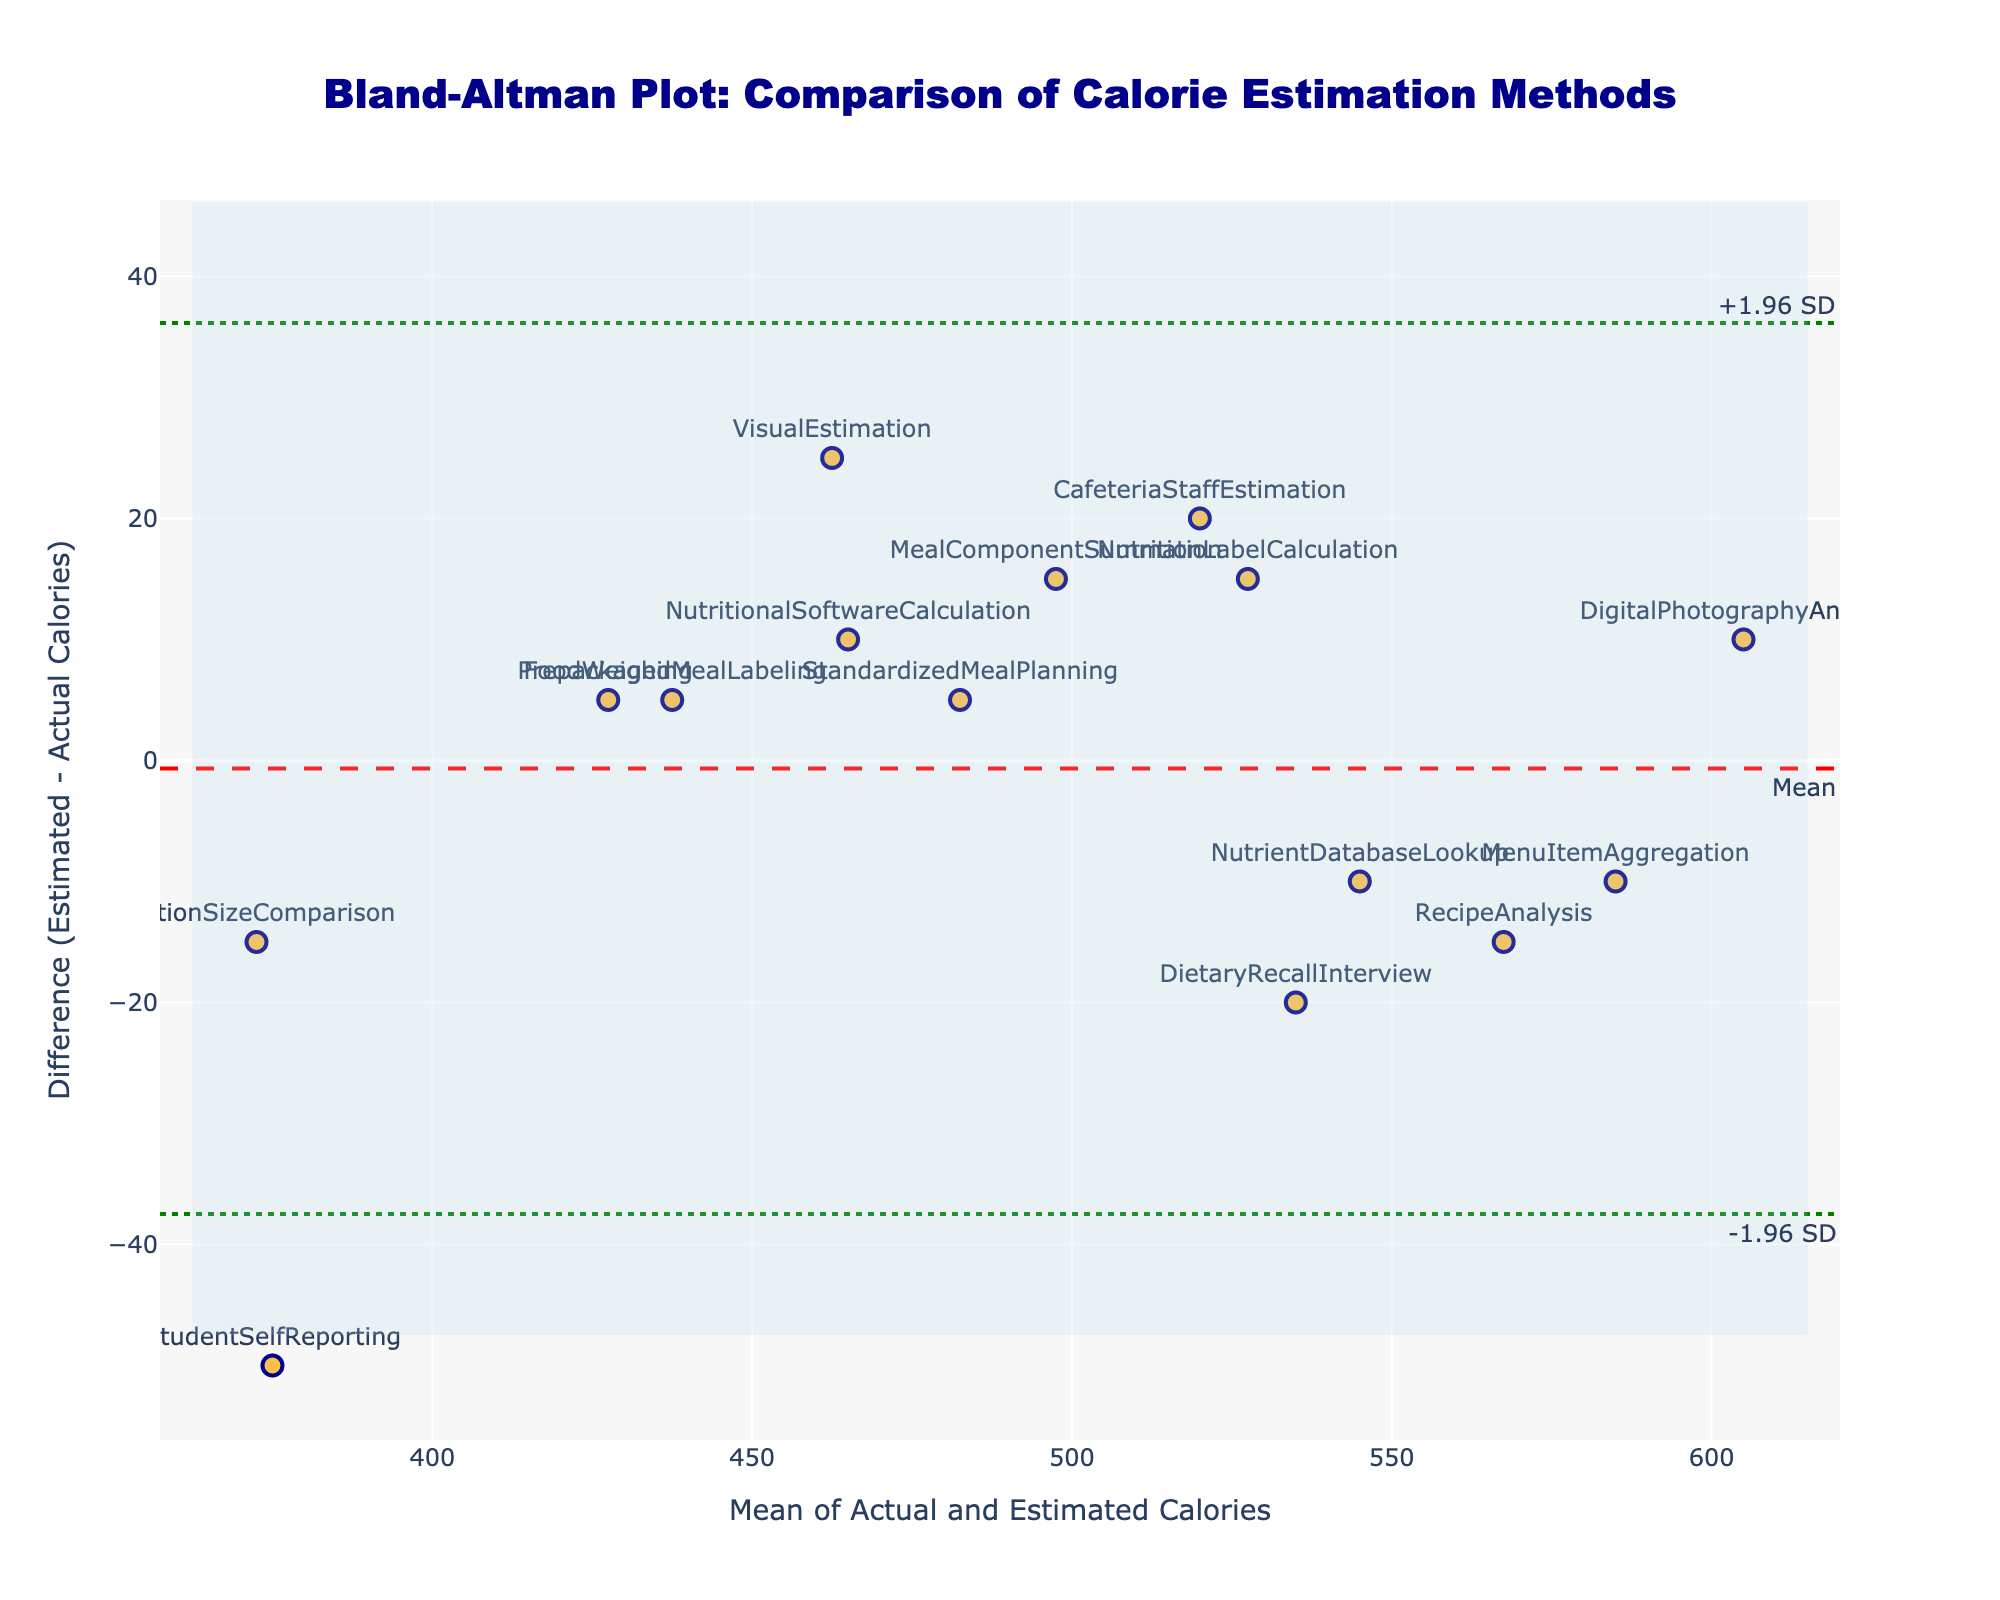Which method has the largest positive difference between estimated and actual calorie intake? The method with the largest positive difference will have the highest point on the y-axis. In the plot, we see that the method "StudentSelfReporting" has the largest positive difference of 50 calories.
Answer: StudentSelfReporting What is the mean difference between the estimated and actual calorie intake? The mean difference is represented by the dashed red line in the plot. The value provided for the mean difference is -2.33 calories.
Answer: -2.33 calories Are there any methods whose difference between estimated and actual calorie intake is negative? A negative difference would be below the 0 line on the y-axis. In the plot, methods like "PortionSizeComparison", "NutrientDatabaseLookup", "RecipeAnalysis", and "DietaryRecallInterview" show negative values.
Answer: Yes Which methods lie within the limits of agreement? Methods within the limits of agreement are those that fall between the dotted green lines. All methods are within the limits of agreement, which range from -27.84 to 23.18 calories.
Answer: All Which method is closest to the mean difference? The mean difference is represented by the red dashed line. The method closest to this line is "NutritionLabelCalculation."
Answer: NutritionLabelCalculation Which method has the most significant negative discrepancy between estimated and actual calorie intake? The method with the most negative difference will have the lowest point on the y-axis. In the plot, the "StudentSelfReporting" method has the most significant negative difference of -50 calories.
Answer: StudentSelfReporting What is the range of the limits of agreement? The limits of agreement are represented by the dotted green lines. The upper limit is 23.18 calories, and the lower limit is -27.84 calories, making the range 23.18 - (-27.84) = 51.02 calories.
Answer: 51.02 calories What is the primary visual feature used to denote the data points for each method on the plot? The data points for each method are denoted by orange markers with dark blue borders.
Answer: Orange markers What is the average of the actual and estimated calorie intake for the "DigitalPhotographyAnalysis" method? For "DigitalPhotographyAnalysis," the actual calorie intake is 600, and the estimated is 610. The average is (600 + 610) / 2 = 605 calories.
Answer: 605 calories 